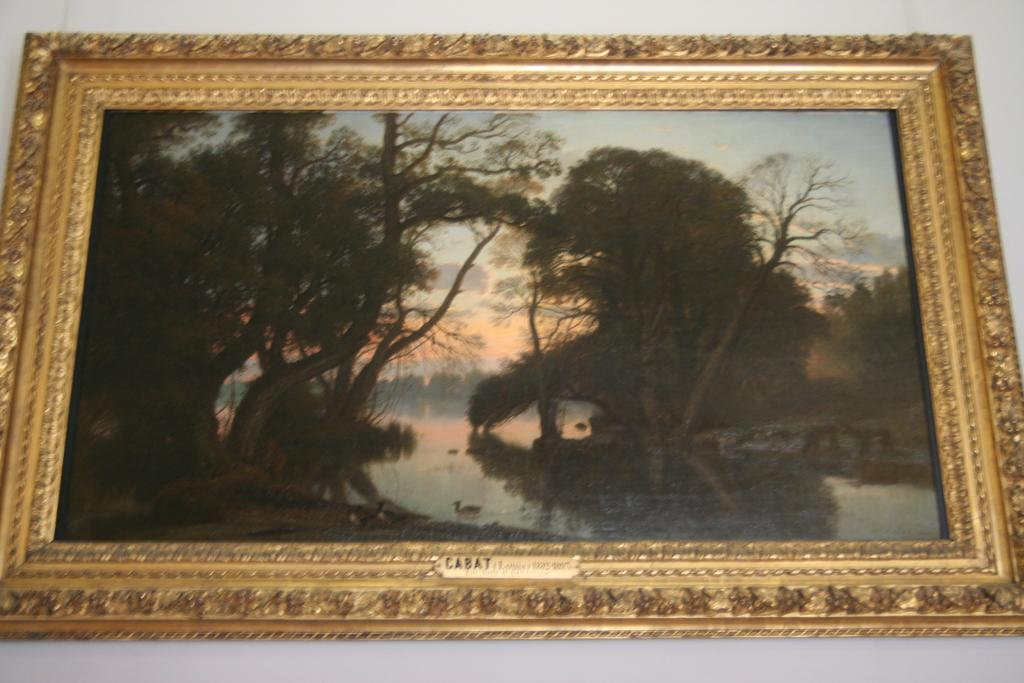What object is present in the image that typically holds a picture? There is a photo frame in the image. What is shown inside the photo frame? The photo frame contains a picture. What elements can be seen in the picture? The picture depicts trees, water, a duck, and the sky. What type of band can be seen in the picture? There is no band present in the image. 